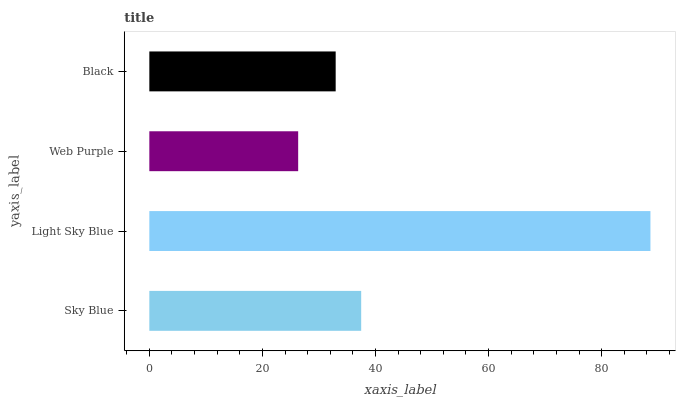Is Web Purple the minimum?
Answer yes or no. Yes. Is Light Sky Blue the maximum?
Answer yes or no. Yes. Is Light Sky Blue the minimum?
Answer yes or no. No. Is Web Purple the maximum?
Answer yes or no. No. Is Light Sky Blue greater than Web Purple?
Answer yes or no. Yes. Is Web Purple less than Light Sky Blue?
Answer yes or no. Yes. Is Web Purple greater than Light Sky Blue?
Answer yes or no. No. Is Light Sky Blue less than Web Purple?
Answer yes or no. No. Is Sky Blue the high median?
Answer yes or no. Yes. Is Black the low median?
Answer yes or no. Yes. Is Web Purple the high median?
Answer yes or no. No. Is Sky Blue the low median?
Answer yes or no. No. 